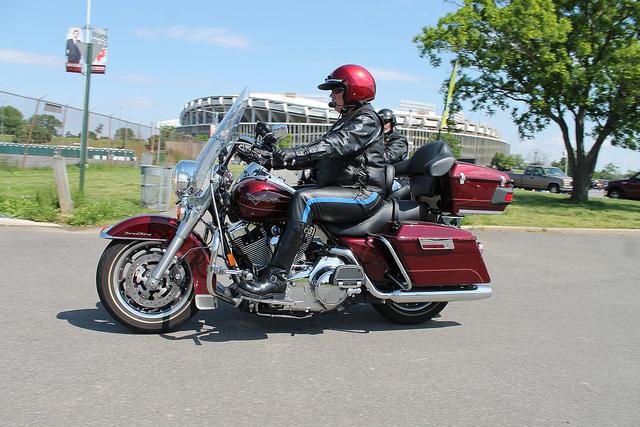Does the helmet have a microphone?
Quick response, please. Yes. Is there a stadium nearby?
Keep it brief. Yes. Is the motorcycle kidnapping the man?
Concise answer only. No. How many crotch rockets are in this picture?
Answer briefly. 0. 